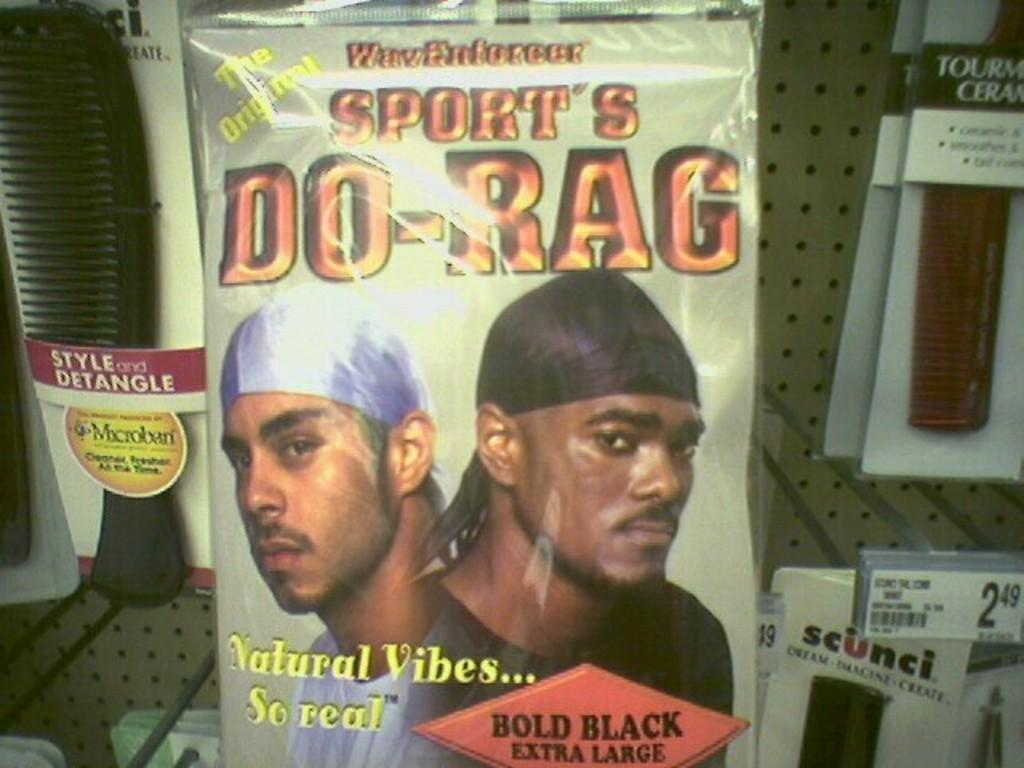What is the main subject of the image? There is a poster in the image. What can be seen on the poster? The poster contains images of two men. Where are the combs in packets located in the image? There are combs in packets on both the right and left sides of the image. What can be seen in the background of the image? There is a board visible in the background of the image. What time of day is depicted in the image? The time of day is not depicted in the image, as there are no indications of morning or any other time. What type of force is being applied to the combs in the image? There is no force being applied to the combs in the image, as they are simply packaged and not in use. 